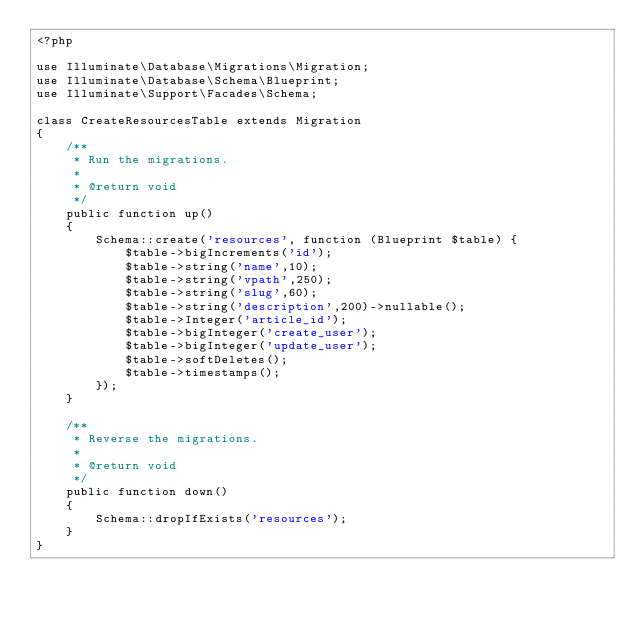Convert code to text. <code><loc_0><loc_0><loc_500><loc_500><_PHP_><?php

use Illuminate\Database\Migrations\Migration;
use Illuminate\Database\Schema\Blueprint;
use Illuminate\Support\Facades\Schema;

class CreateResourcesTable extends Migration
{
    /**
     * Run the migrations.
     *
     * @return void
     */
    public function up()
    {
        Schema::create('resources', function (Blueprint $table) {
            $table->bigIncrements('id');
            $table->string('name',10);
            $table->string('vpath',250);
            $table->string('slug',60);
            $table->string('description',200)->nullable();
            $table->Integer('article_id');
            $table->bigInteger('create_user');
            $table->bigInteger('update_user');
            $table->softDeletes();
            $table->timestamps();
        });
    }

    /**
     * Reverse the migrations.
     *
     * @return void
     */
    public function down()
    {
        Schema::dropIfExists('resources');
    }
}
</code> 